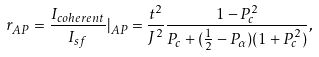<formula> <loc_0><loc_0><loc_500><loc_500>r _ { A P } = \frac { I _ { c o h e r e n t } } { I _ { s f } } | _ { A P } = \frac { t ^ { 2 } } { J ^ { 2 } } \frac { 1 - P _ { c } ^ { 2 } } { P _ { c } + ( \frac { 1 } { 2 } - P _ { \alpha } ) ( 1 + P _ { c } ^ { 2 } ) } ,</formula> 